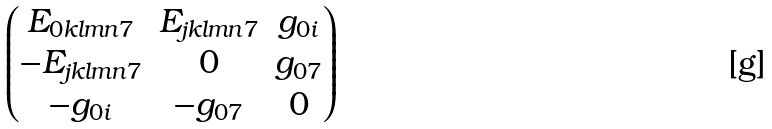Convert formula to latex. <formula><loc_0><loc_0><loc_500><loc_500>\begin{pmatrix} E _ { 0 k l m n 7 } & E _ { j k l m n 7 } & g _ { 0 i } \\ - E _ { j k l m n 7 } & 0 & g _ { 0 7 } \\ - g _ { 0 i } & - g _ { 0 7 } & 0 \end{pmatrix}</formula> 